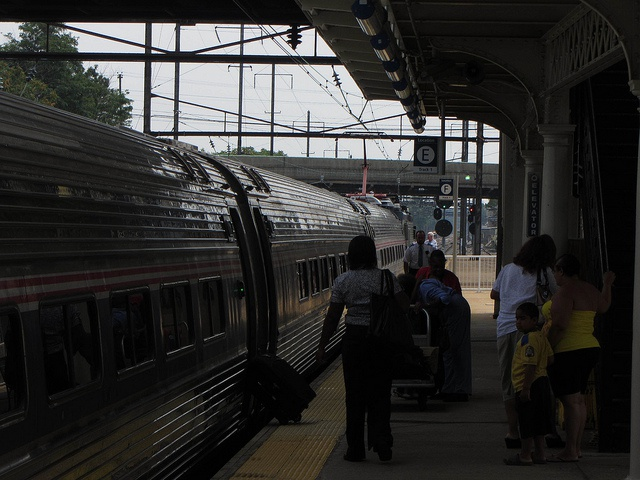Describe the objects in this image and their specific colors. I can see train in black, gray, and darkgray tones, people in black and gray tones, people in black and darkgreen tones, people in black, darkgreen, and gray tones, and people in black, navy, and gray tones in this image. 